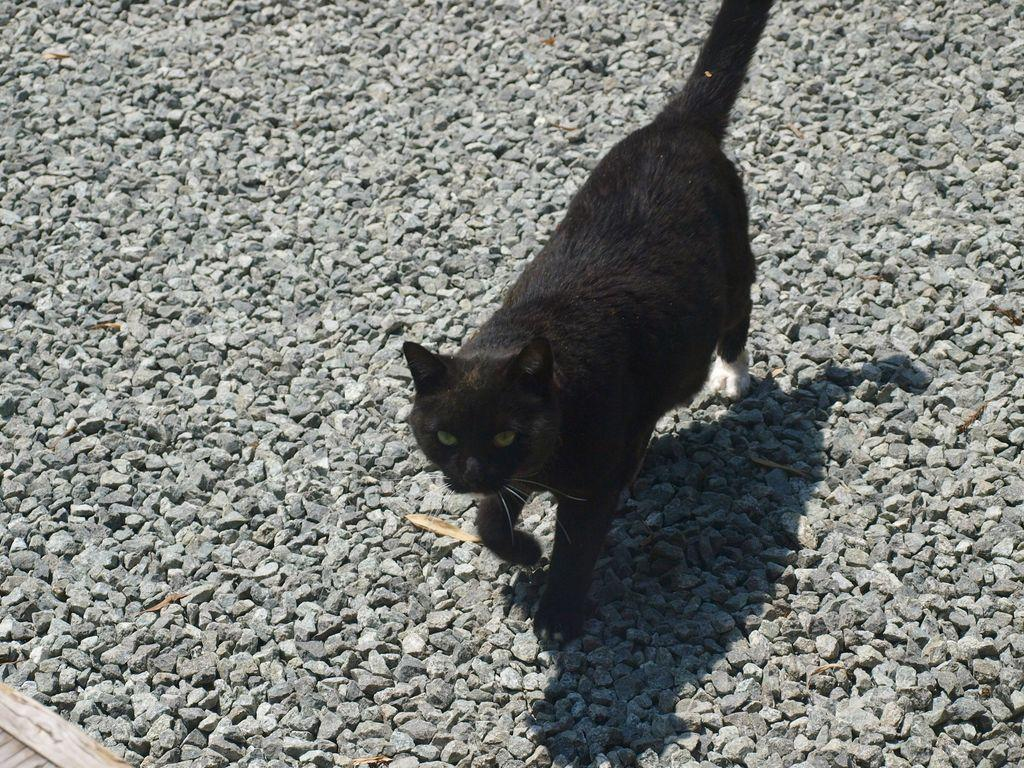What type of animal is in the image? There is a black cat in the image. What is the cat doing in the image? The black cat is walking on stones. What type of cheese is the cat eating in the image? There is no cheese present in the image; the cat is walking on stones. What language is the cat speaking in the image? Cats do not speak human languages, and there is no indication of any language being spoken in the image. 